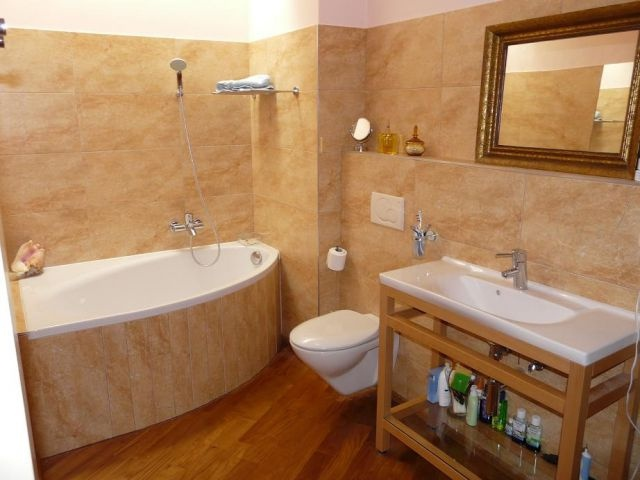Describe the objects in this image and their specific colors. I can see toilet in ivory, tan, gray, and darkgray tones and sink in ivory, tan, and lightgray tones in this image. 